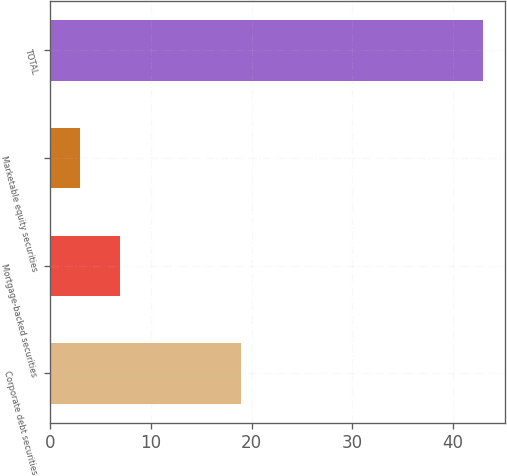Convert chart to OTSL. <chart><loc_0><loc_0><loc_500><loc_500><bar_chart><fcel>Corporate debt securities<fcel>Mortgage-backed securities<fcel>Marketable equity securities<fcel>TOTAL<nl><fcel>19<fcel>7<fcel>3<fcel>43<nl></chart> 